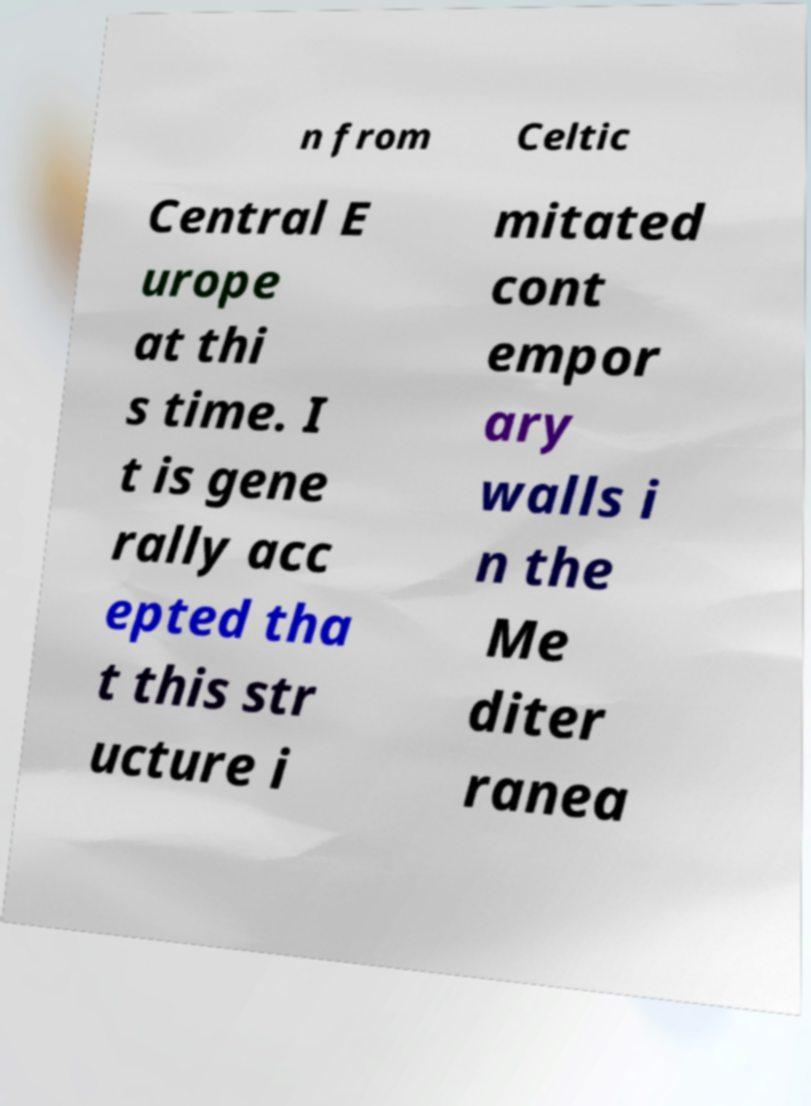Please read and relay the text visible in this image. What does it say? n from Celtic Central E urope at thi s time. I t is gene rally acc epted tha t this str ucture i mitated cont empor ary walls i n the Me diter ranea 